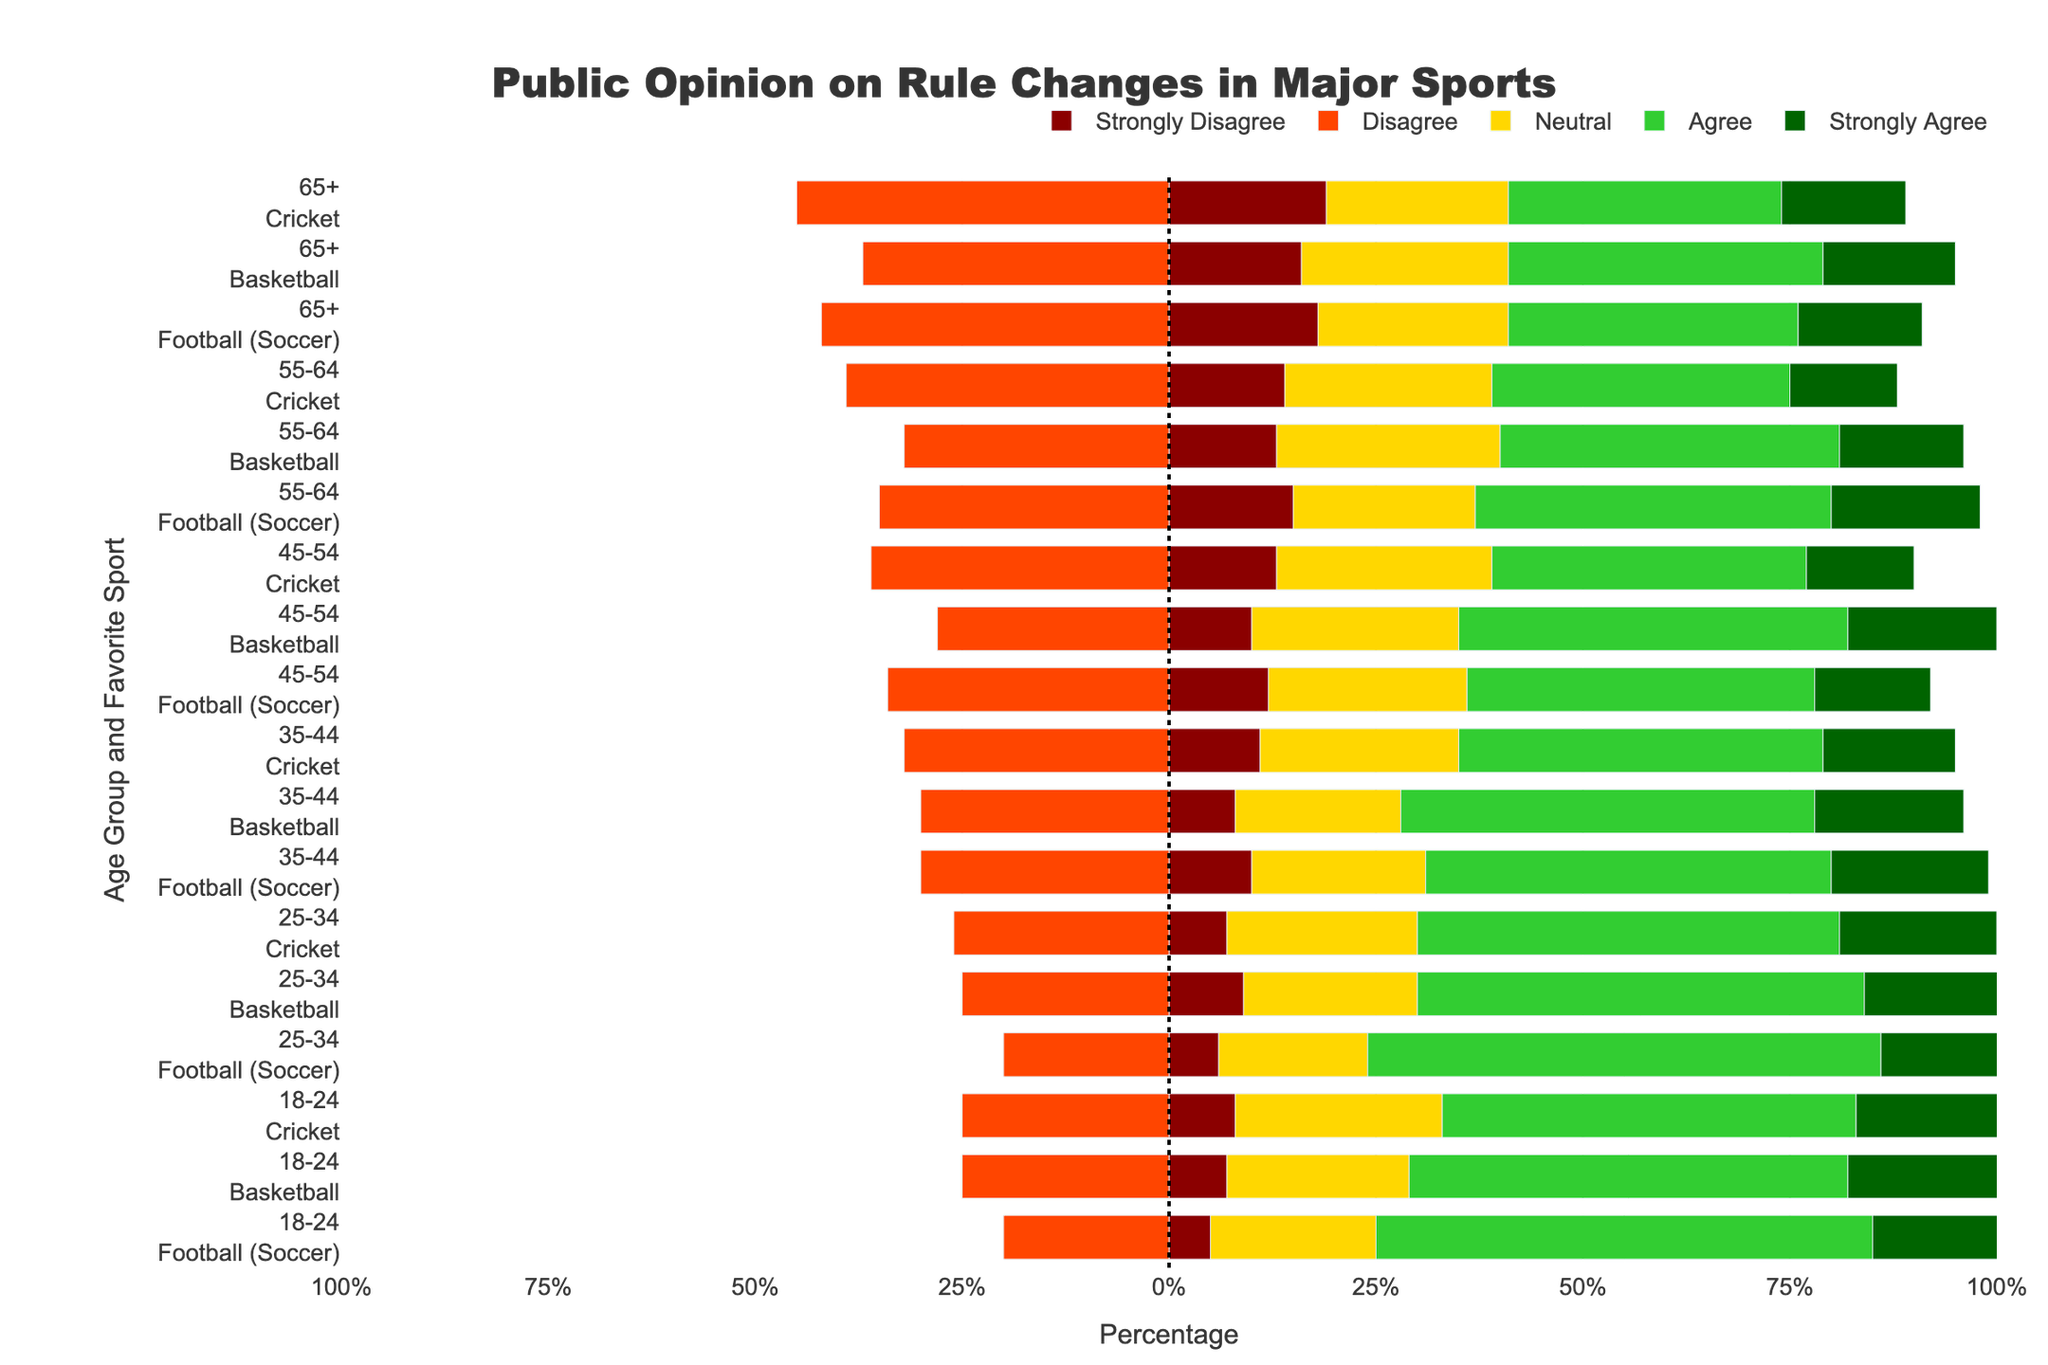Which age group and sport have the highest percentage of 'agree' and 'strongly agree' combined? To find the group with the highest percentage of 'agree' and 'strongly agree' combined, look at the green and dark green sections of the bars. The highest combined percentage is found in the 25-34 age group for "Football (Soccer)" with a combined percentage of 62 (37+25).
Answer: 25-34, Football (Soccer) How does the opinion of the 65+ age group differ between Football (Soccer) and Cricket in terms of disagreement (strongly disagree and disagree)? Compare the red and orange sections of the bar for the 65+ age group in both "Football (Soccer)" and "Cricket." For Football (Soccer), the disagreement is 42% (18+24). For Cricket, it is 45% (19+26).
Answer: 65+, Football (Soccer) has a 3% lower disagreement than Cricket What is the sum of the 'neutral' responses for the 35-44 age group across all sports? Add up the yellow sections of the bars for the 35-44 age group: Football (Soccer) (21%), Basketball (20%), and Cricket (24%). Therefore, the sum is 21+20+24 = 65.
Answer: 65 Which sport has the most balanced opinions among the 45-54 age group? A balanced opinion would have relatively even segments across all opinions. For the 45-54 age group, Football (Soccer) shows the most balanced segments, each being roughly equal without any section dominating. Compare this to the other sports where some sections are significantly larger.
Answer: Football (Soccer) For the 18-24 age group, what is the difference in the 'strongly agree' percentage between Football (Soccer) and Basketball? Look at the dark green sections for both sports in the 18-24 age group: Football (Soccer) has 25%, and Basketball has 23%. The difference is 25-23 = 2.
Answer: 2% In terms of visual appearance, which age group has the most dominant neutral stance across all sports? The yellow section of the bar represents the neutral stance. The 45-54 age group shows the most dominant neutral stance across all sports, with values of 24%, 25%, and 26% for Football (Soccer), Basketball, and Cricket, respectively.
Answer: 45-54 Which age group shows the least overall disagreement (strongly disagree and disagree) for Basketball? Sum the red and orange sections for Basketball in each age group and compare. 18-24: 25 (7+18), 25-34: 25 (9+16), 35-44: 30 (8+22), 45-54: 28 (10+18), 55-64: 32 (13+19), 65+: 37 (16+21). The least disagreement is found in the 18-24 and 25-34 groups, both at 25.
Answer: 18-24, 25-34 Compare the percentage of 'strongly disagree' among 55-64 age group across all sports. Which sport shows the highest percentage? Look at the red sections for the 55-64 age group across all sports: Football (Soccer) (15%), Basketball (13%), Cricket (14%). Cricket has the highest percentage of 'strongly disagree,' which is 14%.
Answer: Cricket What percentage of 25-34 age group Cricket fans 'agree' and 'strongly agree' combined to rule changes? Combine the green sections for Cricket in the 25-34 age group: 32% (agree) and 19% (strongly agree). The combined percentage is 32+19 = 51.
Answer: 51% 